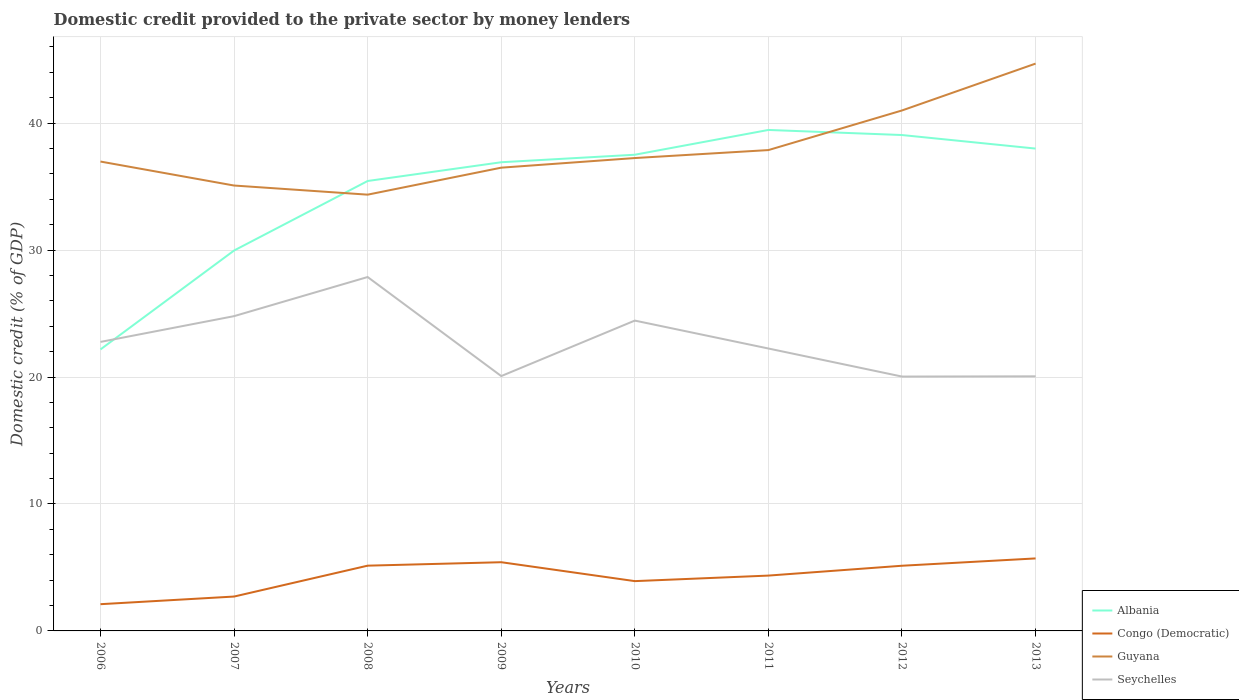Across all years, what is the maximum domestic credit provided to the private sector by money lenders in Congo (Democratic)?
Ensure brevity in your answer.  2.11. What is the total domestic credit provided to the private sector by money lenders in Seychelles in the graph?
Provide a succinct answer. 2.21. What is the difference between the highest and the second highest domestic credit provided to the private sector by money lenders in Congo (Democratic)?
Your answer should be very brief. 3.61. What is the difference between the highest and the lowest domestic credit provided to the private sector by money lenders in Congo (Democratic)?
Keep it short and to the point. 5. Is the domestic credit provided to the private sector by money lenders in Congo (Democratic) strictly greater than the domestic credit provided to the private sector by money lenders in Albania over the years?
Your response must be concise. Yes. Does the graph contain any zero values?
Offer a terse response. No. Does the graph contain grids?
Provide a succinct answer. Yes. Where does the legend appear in the graph?
Ensure brevity in your answer.  Bottom right. What is the title of the graph?
Ensure brevity in your answer.  Domestic credit provided to the private sector by money lenders. Does "Saudi Arabia" appear as one of the legend labels in the graph?
Make the answer very short. No. What is the label or title of the X-axis?
Keep it short and to the point. Years. What is the label or title of the Y-axis?
Provide a short and direct response. Domestic credit (% of GDP). What is the Domestic credit (% of GDP) of Albania in 2006?
Offer a terse response. 22.17. What is the Domestic credit (% of GDP) of Congo (Democratic) in 2006?
Give a very brief answer. 2.11. What is the Domestic credit (% of GDP) in Guyana in 2006?
Make the answer very short. 36.97. What is the Domestic credit (% of GDP) of Seychelles in 2006?
Your response must be concise. 22.76. What is the Domestic credit (% of GDP) of Albania in 2007?
Make the answer very short. 29.96. What is the Domestic credit (% of GDP) of Congo (Democratic) in 2007?
Keep it short and to the point. 2.71. What is the Domestic credit (% of GDP) of Guyana in 2007?
Your answer should be very brief. 35.08. What is the Domestic credit (% of GDP) in Seychelles in 2007?
Offer a very short reply. 24.79. What is the Domestic credit (% of GDP) of Albania in 2008?
Provide a short and direct response. 35.44. What is the Domestic credit (% of GDP) of Congo (Democratic) in 2008?
Provide a succinct answer. 5.14. What is the Domestic credit (% of GDP) in Guyana in 2008?
Your answer should be very brief. 34.36. What is the Domestic credit (% of GDP) of Seychelles in 2008?
Keep it short and to the point. 27.88. What is the Domestic credit (% of GDP) of Albania in 2009?
Keep it short and to the point. 36.92. What is the Domestic credit (% of GDP) of Congo (Democratic) in 2009?
Provide a short and direct response. 5.41. What is the Domestic credit (% of GDP) in Guyana in 2009?
Give a very brief answer. 36.49. What is the Domestic credit (% of GDP) in Seychelles in 2009?
Keep it short and to the point. 20.07. What is the Domestic credit (% of GDP) of Albania in 2010?
Provide a short and direct response. 37.51. What is the Domestic credit (% of GDP) in Congo (Democratic) in 2010?
Your answer should be compact. 3.92. What is the Domestic credit (% of GDP) in Guyana in 2010?
Ensure brevity in your answer.  37.25. What is the Domestic credit (% of GDP) of Seychelles in 2010?
Provide a succinct answer. 24.45. What is the Domestic credit (% of GDP) of Albania in 2011?
Your answer should be very brief. 39.46. What is the Domestic credit (% of GDP) of Congo (Democratic) in 2011?
Provide a short and direct response. 4.36. What is the Domestic credit (% of GDP) in Guyana in 2011?
Keep it short and to the point. 37.88. What is the Domestic credit (% of GDP) of Seychelles in 2011?
Provide a succinct answer. 22.25. What is the Domestic credit (% of GDP) in Albania in 2012?
Give a very brief answer. 39.06. What is the Domestic credit (% of GDP) of Congo (Democratic) in 2012?
Your answer should be compact. 5.13. What is the Domestic credit (% of GDP) of Guyana in 2012?
Provide a succinct answer. 41. What is the Domestic credit (% of GDP) of Seychelles in 2012?
Give a very brief answer. 20.04. What is the Domestic credit (% of GDP) in Albania in 2013?
Make the answer very short. 37.99. What is the Domestic credit (% of GDP) of Congo (Democratic) in 2013?
Offer a terse response. 5.71. What is the Domestic credit (% of GDP) in Guyana in 2013?
Your response must be concise. 44.69. What is the Domestic credit (% of GDP) in Seychelles in 2013?
Make the answer very short. 20.05. Across all years, what is the maximum Domestic credit (% of GDP) in Albania?
Offer a very short reply. 39.46. Across all years, what is the maximum Domestic credit (% of GDP) in Congo (Democratic)?
Ensure brevity in your answer.  5.71. Across all years, what is the maximum Domestic credit (% of GDP) in Guyana?
Your answer should be very brief. 44.69. Across all years, what is the maximum Domestic credit (% of GDP) of Seychelles?
Ensure brevity in your answer.  27.88. Across all years, what is the minimum Domestic credit (% of GDP) of Albania?
Give a very brief answer. 22.17. Across all years, what is the minimum Domestic credit (% of GDP) in Congo (Democratic)?
Your answer should be very brief. 2.11. Across all years, what is the minimum Domestic credit (% of GDP) of Guyana?
Make the answer very short. 34.36. Across all years, what is the minimum Domestic credit (% of GDP) in Seychelles?
Ensure brevity in your answer.  20.04. What is the total Domestic credit (% of GDP) in Albania in the graph?
Offer a very short reply. 278.52. What is the total Domestic credit (% of GDP) of Congo (Democratic) in the graph?
Make the answer very short. 34.49. What is the total Domestic credit (% of GDP) of Guyana in the graph?
Offer a terse response. 303.72. What is the total Domestic credit (% of GDP) of Seychelles in the graph?
Give a very brief answer. 182.29. What is the difference between the Domestic credit (% of GDP) of Albania in 2006 and that in 2007?
Provide a short and direct response. -7.79. What is the difference between the Domestic credit (% of GDP) in Congo (Democratic) in 2006 and that in 2007?
Give a very brief answer. -0.6. What is the difference between the Domestic credit (% of GDP) in Guyana in 2006 and that in 2007?
Offer a terse response. 1.89. What is the difference between the Domestic credit (% of GDP) in Seychelles in 2006 and that in 2007?
Your response must be concise. -2.03. What is the difference between the Domestic credit (% of GDP) in Albania in 2006 and that in 2008?
Keep it short and to the point. -13.27. What is the difference between the Domestic credit (% of GDP) in Congo (Democratic) in 2006 and that in 2008?
Keep it short and to the point. -3.03. What is the difference between the Domestic credit (% of GDP) of Guyana in 2006 and that in 2008?
Make the answer very short. 2.61. What is the difference between the Domestic credit (% of GDP) of Seychelles in 2006 and that in 2008?
Keep it short and to the point. -5.11. What is the difference between the Domestic credit (% of GDP) in Albania in 2006 and that in 2009?
Make the answer very short. -14.74. What is the difference between the Domestic credit (% of GDP) of Congo (Democratic) in 2006 and that in 2009?
Your response must be concise. -3.31. What is the difference between the Domestic credit (% of GDP) of Guyana in 2006 and that in 2009?
Keep it short and to the point. 0.48. What is the difference between the Domestic credit (% of GDP) of Seychelles in 2006 and that in 2009?
Offer a terse response. 2.69. What is the difference between the Domestic credit (% of GDP) of Albania in 2006 and that in 2010?
Provide a succinct answer. -15.34. What is the difference between the Domestic credit (% of GDP) in Congo (Democratic) in 2006 and that in 2010?
Your response must be concise. -1.82. What is the difference between the Domestic credit (% of GDP) in Guyana in 2006 and that in 2010?
Offer a terse response. -0.28. What is the difference between the Domestic credit (% of GDP) of Seychelles in 2006 and that in 2010?
Your answer should be compact. -1.68. What is the difference between the Domestic credit (% of GDP) of Albania in 2006 and that in 2011?
Keep it short and to the point. -17.29. What is the difference between the Domestic credit (% of GDP) in Congo (Democratic) in 2006 and that in 2011?
Provide a short and direct response. -2.25. What is the difference between the Domestic credit (% of GDP) of Guyana in 2006 and that in 2011?
Your answer should be very brief. -0.9. What is the difference between the Domestic credit (% of GDP) in Seychelles in 2006 and that in 2011?
Give a very brief answer. 0.52. What is the difference between the Domestic credit (% of GDP) in Albania in 2006 and that in 2012?
Offer a terse response. -16.89. What is the difference between the Domestic credit (% of GDP) in Congo (Democratic) in 2006 and that in 2012?
Your answer should be very brief. -3.03. What is the difference between the Domestic credit (% of GDP) in Guyana in 2006 and that in 2012?
Provide a short and direct response. -4.02. What is the difference between the Domestic credit (% of GDP) of Seychelles in 2006 and that in 2012?
Your answer should be very brief. 2.73. What is the difference between the Domestic credit (% of GDP) of Albania in 2006 and that in 2013?
Ensure brevity in your answer.  -15.82. What is the difference between the Domestic credit (% of GDP) of Congo (Democratic) in 2006 and that in 2013?
Provide a short and direct response. -3.6. What is the difference between the Domestic credit (% of GDP) of Guyana in 2006 and that in 2013?
Provide a short and direct response. -7.71. What is the difference between the Domestic credit (% of GDP) in Seychelles in 2006 and that in 2013?
Your answer should be compact. 2.71. What is the difference between the Domestic credit (% of GDP) of Albania in 2007 and that in 2008?
Keep it short and to the point. -5.48. What is the difference between the Domestic credit (% of GDP) of Congo (Democratic) in 2007 and that in 2008?
Give a very brief answer. -2.43. What is the difference between the Domestic credit (% of GDP) of Guyana in 2007 and that in 2008?
Provide a short and direct response. 0.72. What is the difference between the Domestic credit (% of GDP) of Seychelles in 2007 and that in 2008?
Ensure brevity in your answer.  -3.08. What is the difference between the Domestic credit (% of GDP) in Albania in 2007 and that in 2009?
Ensure brevity in your answer.  -6.95. What is the difference between the Domestic credit (% of GDP) in Congo (Democratic) in 2007 and that in 2009?
Your response must be concise. -2.7. What is the difference between the Domestic credit (% of GDP) of Guyana in 2007 and that in 2009?
Offer a terse response. -1.41. What is the difference between the Domestic credit (% of GDP) of Seychelles in 2007 and that in 2009?
Provide a succinct answer. 4.72. What is the difference between the Domestic credit (% of GDP) in Albania in 2007 and that in 2010?
Your answer should be compact. -7.54. What is the difference between the Domestic credit (% of GDP) in Congo (Democratic) in 2007 and that in 2010?
Your answer should be compact. -1.22. What is the difference between the Domestic credit (% of GDP) of Guyana in 2007 and that in 2010?
Your answer should be compact. -2.16. What is the difference between the Domestic credit (% of GDP) in Seychelles in 2007 and that in 2010?
Your answer should be very brief. 0.35. What is the difference between the Domestic credit (% of GDP) in Albania in 2007 and that in 2011?
Ensure brevity in your answer.  -9.5. What is the difference between the Domestic credit (% of GDP) of Congo (Democratic) in 2007 and that in 2011?
Give a very brief answer. -1.65. What is the difference between the Domestic credit (% of GDP) in Guyana in 2007 and that in 2011?
Your response must be concise. -2.79. What is the difference between the Domestic credit (% of GDP) of Seychelles in 2007 and that in 2011?
Make the answer very short. 2.55. What is the difference between the Domestic credit (% of GDP) of Albania in 2007 and that in 2012?
Your response must be concise. -9.1. What is the difference between the Domestic credit (% of GDP) of Congo (Democratic) in 2007 and that in 2012?
Offer a very short reply. -2.43. What is the difference between the Domestic credit (% of GDP) in Guyana in 2007 and that in 2012?
Your response must be concise. -5.91. What is the difference between the Domestic credit (% of GDP) in Seychelles in 2007 and that in 2012?
Provide a short and direct response. 4.76. What is the difference between the Domestic credit (% of GDP) of Albania in 2007 and that in 2013?
Ensure brevity in your answer.  -8.03. What is the difference between the Domestic credit (% of GDP) in Congo (Democratic) in 2007 and that in 2013?
Make the answer very short. -3. What is the difference between the Domestic credit (% of GDP) in Guyana in 2007 and that in 2013?
Offer a terse response. -9.6. What is the difference between the Domestic credit (% of GDP) in Seychelles in 2007 and that in 2013?
Your answer should be very brief. 4.74. What is the difference between the Domestic credit (% of GDP) in Albania in 2008 and that in 2009?
Your response must be concise. -1.48. What is the difference between the Domestic credit (% of GDP) of Congo (Democratic) in 2008 and that in 2009?
Offer a terse response. -0.27. What is the difference between the Domestic credit (% of GDP) of Guyana in 2008 and that in 2009?
Your answer should be very brief. -2.13. What is the difference between the Domestic credit (% of GDP) in Seychelles in 2008 and that in 2009?
Give a very brief answer. 7.8. What is the difference between the Domestic credit (% of GDP) in Albania in 2008 and that in 2010?
Give a very brief answer. -2.07. What is the difference between the Domestic credit (% of GDP) of Congo (Democratic) in 2008 and that in 2010?
Ensure brevity in your answer.  1.22. What is the difference between the Domestic credit (% of GDP) of Guyana in 2008 and that in 2010?
Provide a succinct answer. -2.88. What is the difference between the Domestic credit (% of GDP) of Seychelles in 2008 and that in 2010?
Offer a terse response. 3.43. What is the difference between the Domestic credit (% of GDP) in Albania in 2008 and that in 2011?
Make the answer very short. -4.02. What is the difference between the Domestic credit (% of GDP) in Congo (Democratic) in 2008 and that in 2011?
Provide a succinct answer. 0.78. What is the difference between the Domestic credit (% of GDP) in Guyana in 2008 and that in 2011?
Ensure brevity in your answer.  -3.51. What is the difference between the Domestic credit (% of GDP) of Seychelles in 2008 and that in 2011?
Offer a very short reply. 5.63. What is the difference between the Domestic credit (% of GDP) in Albania in 2008 and that in 2012?
Provide a succinct answer. -3.62. What is the difference between the Domestic credit (% of GDP) of Congo (Democratic) in 2008 and that in 2012?
Offer a very short reply. 0.01. What is the difference between the Domestic credit (% of GDP) in Guyana in 2008 and that in 2012?
Keep it short and to the point. -6.63. What is the difference between the Domestic credit (% of GDP) of Seychelles in 2008 and that in 2012?
Your response must be concise. 7.84. What is the difference between the Domestic credit (% of GDP) in Albania in 2008 and that in 2013?
Your answer should be very brief. -2.55. What is the difference between the Domestic credit (% of GDP) of Congo (Democratic) in 2008 and that in 2013?
Give a very brief answer. -0.57. What is the difference between the Domestic credit (% of GDP) in Guyana in 2008 and that in 2013?
Make the answer very short. -10.32. What is the difference between the Domestic credit (% of GDP) of Seychelles in 2008 and that in 2013?
Offer a terse response. 7.82. What is the difference between the Domestic credit (% of GDP) of Albania in 2009 and that in 2010?
Offer a very short reply. -0.59. What is the difference between the Domestic credit (% of GDP) in Congo (Democratic) in 2009 and that in 2010?
Your answer should be very brief. 1.49. What is the difference between the Domestic credit (% of GDP) of Guyana in 2009 and that in 2010?
Make the answer very short. -0.76. What is the difference between the Domestic credit (% of GDP) in Seychelles in 2009 and that in 2010?
Make the answer very short. -4.37. What is the difference between the Domestic credit (% of GDP) in Albania in 2009 and that in 2011?
Make the answer very short. -2.54. What is the difference between the Domestic credit (% of GDP) of Congo (Democratic) in 2009 and that in 2011?
Offer a terse response. 1.05. What is the difference between the Domestic credit (% of GDP) of Guyana in 2009 and that in 2011?
Keep it short and to the point. -1.39. What is the difference between the Domestic credit (% of GDP) in Seychelles in 2009 and that in 2011?
Your response must be concise. -2.17. What is the difference between the Domestic credit (% of GDP) of Albania in 2009 and that in 2012?
Your answer should be very brief. -2.14. What is the difference between the Domestic credit (% of GDP) in Congo (Democratic) in 2009 and that in 2012?
Provide a short and direct response. 0.28. What is the difference between the Domestic credit (% of GDP) in Guyana in 2009 and that in 2012?
Your response must be concise. -4.51. What is the difference between the Domestic credit (% of GDP) in Seychelles in 2009 and that in 2012?
Offer a terse response. 0.04. What is the difference between the Domestic credit (% of GDP) in Albania in 2009 and that in 2013?
Provide a short and direct response. -1.08. What is the difference between the Domestic credit (% of GDP) in Congo (Democratic) in 2009 and that in 2013?
Give a very brief answer. -0.3. What is the difference between the Domestic credit (% of GDP) in Guyana in 2009 and that in 2013?
Make the answer very short. -8.2. What is the difference between the Domestic credit (% of GDP) in Seychelles in 2009 and that in 2013?
Provide a succinct answer. 0.02. What is the difference between the Domestic credit (% of GDP) of Albania in 2010 and that in 2011?
Your answer should be very brief. -1.95. What is the difference between the Domestic credit (% of GDP) of Congo (Democratic) in 2010 and that in 2011?
Give a very brief answer. -0.44. What is the difference between the Domestic credit (% of GDP) of Guyana in 2010 and that in 2011?
Your answer should be compact. -0.63. What is the difference between the Domestic credit (% of GDP) in Seychelles in 2010 and that in 2011?
Your response must be concise. 2.2. What is the difference between the Domestic credit (% of GDP) in Albania in 2010 and that in 2012?
Your answer should be very brief. -1.55. What is the difference between the Domestic credit (% of GDP) in Congo (Democratic) in 2010 and that in 2012?
Your answer should be very brief. -1.21. What is the difference between the Domestic credit (% of GDP) of Guyana in 2010 and that in 2012?
Your answer should be compact. -3.75. What is the difference between the Domestic credit (% of GDP) of Seychelles in 2010 and that in 2012?
Offer a very short reply. 4.41. What is the difference between the Domestic credit (% of GDP) of Albania in 2010 and that in 2013?
Your answer should be compact. -0.49. What is the difference between the Domestic credit (% of GDP) of Congo (Democratic) in 2010 and that in 2013?
Your answer should be very brief. -1.79. What is the difference between the Domestic credit (% of GDP) of Guyana in 2010 and that in 2013?
Your response must be concise. -7.44. What is the difference between the Domestic credit (% of GDP) of Seychelles in 2010 and that in 2013?
Provide a short and direct response. 4.39. What is the difference between the Domestic credit (% of GDP) of Albania in 2011 and that in 2012?
Make the answer very short. 0.4. What is the difference between the Domestic credit (% of GDP) of Congo (Democratic) in 2011 and that in 2012?
Your answer should be compact. -0.78. What is the difference between the Domestic credit (% of GDP) in Guyana in 2011 and that in 2012?
Provide a succinct answer. -3.12. What is the difference between the Domestic credit (% of GDP) of Seychelles in 2011 and that in 2012?
Provide a succinct answer. 2.21. What is the difference between the Domestic credit (% of GDP) of Albania in 2011 and that in 2013?
Your answer should be compact. 1.47. What is the difference between the Domestic credit (% of GDP) in Congo (Democratic) in 2011 and that in 2013?
Your answer should be compact. -1.35. What is the difference between the Domestic credit (% of GDP) of Guyana in 2011 and that in 2013?
Keep it short and to the point. -6.81. What is the difference between the Domestic credit (% of GDP) of Seychelles in 2011 and that in 2013?
Make the answer very short. 2.19. What is the difference between the Domestic credit (% of GDP) of Albania in 2012 and that in 2013?
Provide a short and direct response. 1.07. What is the difference between the Domestic credit (% of GDP) in Congo (Democratic) in 2012 and that in 2013?
Your answer should be very brief. -0.58. What is the difference between the Domestic credit (% of GDP) of Guyana in 2012 and that in 2013?
Make the answer very short. -3.69. What is the difference between the Domestic credit (% of GDP) of Seychelles in 2012 and that in 2013?
Make the answer very short. -0.02. What is the difference between the Domestic credit (% of GDP) in Albania in 2006 and the Domestic credit (% of GDP) in Congo (Democratic) in 2007?
Your answer should be very brief. 19.47. What is the difference between the Domestic credit (% of GDP) of Albania in 2006 and the Domestic credit (% of GDP) of Guyana in 2007?
Your answer should be very brief. -12.91. What is the difference between the Domestic credit (% of GDP) in Albania in 2006 and the Domestic credit (% of GDP) in Seychelles in 2007?
Your response must be concise. -2.62. What is the difference between the Domestic credit (% of GDP) of Congo (Democratic) in 2006 and the Domestic credit (% of GDP) of Guyana in 2007?
Your answer should be compact. -32.98. What is the difference between the Domestic credit (% of GDP) of Congo (Democratic) in 2006 and the Domestic credit (% of GDP) of Seychelles in 2007?
Offer a terse response. -22.69. What is the difference between the Domestic credit (% of GDP) in Guyana in 2006 and the Domestic credit (% of GDP) in Seychelles in 2007?
Your answer should be compact. 12.18. What is the difference between the Domestic credit (% of GDP) of Albania in 2006 and the Domestic credit (% of GDP) of Congo (Democratic) in 2008?
Provide a succinct answer. 17.03. What is the difference between the Domestic credit (% of GDP) in Albania in 2006 and the Domestic credit (% of GDP) in Guyana in 2008?
Keep it short and to the point. -12.19. What is the difference between the Domestic credit (% of GDP) of Albania in 2006 and the Domestic credit (% of GDP) of Seychelles in 2008?
Ensure brevity in your answer.  -5.7. What is the difference between the Domestic credit (% of GDP) of Congo (Democratic) in 2006 and the Domestic credit (% of GDP) of Guyana in 2008?
Make the answer very short. -32.26. What is the difference between the Domestic credit (% of GDP) of Congo (Democratic) in 2006 and the Domestic credit (% of GDP) of Seychelles in 2008?
Your answer should be very brief. -25.77. What is the difference between the Domestic credit (% of GDP) in Guyana in 2006 and the Domestic credit (% of GDP) in Seychelles in 2008?
Provide a succinct answer. 9.1. What is the difference between the Domestic credit (% of GDP) in Albania in 2006 and the Domestic credit (% of GDP) in Congo (Democratic) in 2009?
Give a very brief answer. 16.76. What is the difference between the Domestic credit (% of GDP) in Albania in 2006 and the Domestic credit (% of GDP) in Guyana in 2009?
Your answer should be compact. -14.32. What is the difference between the Domestic credit (% of GDP) in Albania in 2006 and the Domestic credit (% of GDP) in Seychelles in 2009?
Provide a succinct answer. 2.1. What is the difference between the Domestic credit (% of GDP) in Congo (Democratic) in 2006 and the Domestic credit (% of GDP) in Guyana in 2009?
Your answer should be compact. -34.38. What is the difference between the Domestic credit (% of GDP) of Congo (Democratic) in 2006 and the Domestic credit (% of GDP) of Seychelles in 2009?
Offer a terse response. -17.97. What is the difference between the Domestic credit (% of GDP) of Guyana in 2006 and the Domestic credit (% of GDP) of Seychelles in 2009?
Ensure brevity in your answer.  16.9. What is the difference between the Domestic credit (% of GDP) in Albania in 2006 and the Domestic credit (% of GDP) in Congo (Democratic) in 2010?
Your response must be concise. 18.25. What is the difference between the Domestic credit (% of GDP) in Albania in 2006 and the Domestic credit (% of GDP) in Guyana in 2010?
Keep it short and to the point. -15.07. What is the difference between the Domestic credit (% of GDP) of Albania in 2006 and the Domestic credit (% of GDP) of Seychelles in 2010?
Keep it short and to the point. -2.27. What is the difference between the Domestic credit (% of GDP) of Congo (Democratic) in 2006 and the Domestic credit (% of GDP) of Guyana in 2010?
Give a very brief answer. -35.14. What is the difference between the Domestic credit (% of GDP) in Congo (Democratic) in 2006 and the Domestic credit (% of GDP) in Seychelles in 2010?
Make the answer very short. -22.34. What is the difference between the Domestic credit (% of GDP) of Guyana in 2006 and the Domestic credit (% of GDP) of Seychelles in 2010?
Provide a succinct answer. 12.53. What is the difference between the Domestic credit (% of GDP) in Albania in 2006 and the Domestic credit (% of GDP) in Congo (Democratic) in 2011?
Ensure brevity in your answer.  17.81. What is the difference between the Domestic credit (% of GDP) in Albania in 2006 and the Domestic credit (% of GDP) in Guyana in 2011?
Offer a very short reply. -15.7. What is the difference between the Domestic credit (% of GDP) of Albania in 2006 and the Domestic credit (% of GDP) of Seychelles in 2011?
Give a very brief answer. -0.07. What is the difference between the Domestic credit (% of GDP) in Congo (Democratic) in 2006 and the Domestic credit (% of GDP) in Guyana in 2011?
Keep it short and to the point. -35.77. What is the difference between the Domestic credit (% of GDP) in Congo (Democratic) in 2006 and the Domestic credit (% of GDP) in Seychelles in 2011?
Offer a very short reply. -20.14. What is the difference between the Domestic credit (% of GDP) of Guyana in 2006 and the Domestic credit (% of GDP) of Seychelles in 2011?
Your answer should be compact. 14.73. What is the difference between the Domestic credit (% of GDP) of Albania in 2006 and the Domestic credit (% of GDP) of Congo (Democratic) in 2012?
Keep it short and to the point. 17.04. What is the difference between the Domestic credit (% of GDP) in Albania in 2006 and the Domestic credit (% of GDP) in Guyana in 2012?
Provide a short and direct response. -18.82. What is the difference between the Domestic credit (% of GDP) of Albania in 2006 and the Domestic credit (% of GDP) of Seychelles in 2012?
Your answer should be compact. 2.14. What is the difference between the Domestic credit (% of GDP) in Congo (Democratic) in 2006 and the Domestic credit (% of GDP) in Guyana in 2012?
Keep it short and to the point. -38.89. What is the difference between the Domestic credit (% of GDP) of Congo (Democratic) in 2006 and the Domestic credit (% of GDP) of Seychelles in 2012?
Ensure brevity in your answer.  -17.93. What is the difference between the Domestic credit (% of GDP) in Guyana in 2006 and the Domestic credit (% of GDP) in Seychelles in 2012?
Offer a terse response. 16.94. What is the difference between the Domestic credit (% of GDP) of Albania in 2006 and the Domestic credit (% of GDP) of Congo (Democratic) in 2013?
Offer a terse response. 16.46. What is the difference between the Domestic credit (% of GDP) of Albania in 2006 and the Domestic credit (% of GDP) of Guyana in 2013?
Provide a short and direct response. -22.51. What is the difference between the Domestic credit (% of GDP) of Albania in 2006 and the Domestic credit (% of GDP) of Seychelles in 2013?
Your answer should be very brief. 2.12. What is the difference between the Domestic credit (% of GDP) of Congo (Democratic) in 2006 and the Domestic credit (% of GDP) of Guyana in 2013?
Make the answer very short. -42.58. What is the difference between the Domestic credit (% of GDP) of Congo (Democratic) in 2006 and the Domestic credit (% of GDP) of Seychelles in 2013?
Offer a terse response. -17.95. What is the difference between the Domestic credit (% of GDP) of Guyana in 2006 and the Domestic credit (% of GDP) of Seychelles in 2013?
Offer a very short reply. 16.92. What is the difference between the Domestic credit (% of GDP) in Albania in 2007 and the Domestic credit (% of GDP) in Congo (Democratic) in 2008?
Offer a very short reply. 24.82. What is the difference between the Domestic credit (% of GDP) of Albania in 2007 and the Domestic credit (% of GDP) of Guyana in 2008?
Make the answer very short. -4.4. What is the difference between the Domestic credit (% of GDP) of Albania in 2007 and the Domestic credit (% of GDP) of Seychelles in 2008?
Provide a succinct answer. 2.09. What is the difference between the Domestic credit (% of GDP) of Congo (Democratic) in 2007 and the Domestic credit (% of GDP) of Guyana in 2008?
Offer a very short reply. -31.66. What is the difference between the Domestic credit (% of GDP) of Congo (Democratic) in 2007 and the Domestic credit (% of GDP) of Seychelles in 2008?
Your answer should be compact. -25.17. What is the difference between the Domestic credit (% of GDP) in Guyana in 2007 and the Domestic credit (% of GDP) in Seychelles in 2008?
Your answer should be very brief. 7.21. What is the difference between the Domestic credit (% of GDP) of Albania in 2007 and the Domestic credit (% of GDP) of Congo (Democratic) in 2009?
Make the answer very short. 24.55. What is the difference between the Domestic credit (% of GDP) of Albania in 2007 and the Domestic credit (% of GDP) of Guyana in 2009?
Your answer should be very brief. -6.53. What is the difference between the Domestic credit (% of GDP) of Albania in 2007 and the Domestic credit (% of GDP) of Seychelles in 2009?
Offer a very short reply. 9.89. What is the difference between the Domestic credit (% of GDP) in Congo (Democratic) in 2007 and the Domestic credit (% of GDP) in Guyana in 2009?
Keep it short and to the point. -33.78. What is the difference between the Domestic credit (% of GDP) of Congo (Democratic) in 2007 and the Domestic credit (% of GDP) of Seychelles in 2009?
Your response must be concise. -17.37. What is the difference between the Domestic credit (% of GDP) in Guyana in 2007 and the Domestic credit (% of GDP) in Seychelles in 2009?
Your answer should be compact. 15.01. What is the difference between the Domestic credit (% of GDP) in Albania in 2007 and the Domestic credit (% of GDP) in Congo (Democratic) in 2010?
Offer a terse response. 26.04. What is the difference between the Domestic credit (% of GDP) in Albania in 2007 and the Domestic credit (% of GDP) in Guyana in 2010?
Make the answer very short. -7.28. What is the difference between the Domestic credit (% of GDP) in Albania in 2007 and the Domestic credit (% of GDP) in Seychelles in 2010?
Make the answer very short. 5.52. What is the difference between the Domestic credit (% of GDP) of Congo (Democratic) in 2007 and the Domestic credit (% of GDP) of Guyana in 2010?
Offer a terse response. -34.54. What is the difference between the Domestic credit (% of GDP) in Congo (Democratic) in 2007 and the Domestic credit (% of GDP) in Seychelles in 2010?
Your response must be concise. -21.74. What is the difference between the Domestic credit (% of GDP) of Guyana in 2007 and the Domestic credit (% of GDP) of Seychelles in 2010?
Offer a very short reply. 10.64. What is the difference between the Domestic credit (% of GDP) of Albania in 2007 and the Domestic credit (% of GDP) of Congo (Democratic) in 2011?
Offer a very short reply. 25.61. What is the difference between the Domestic credit (% of GDP) of Albania in 2007 and the Domestic credit (% of GDP) of Guyana in 2011?
Provide a succinct answer. -7.91. What is the difference between the Domestic credit (% of GDP) in Albania in 2007 and the Domestic credit (% of GDP) in Seychelles in 2011?
Offer a very short reply. 7.72. What is the difference between the Domestic credit (% of GDP) of Congo (Democratic) in 2007 and the Domestic credit (% of GDP) of Guyana in 2011?
Keep it short and to the point. -35.17. What is the difference between the Domestic credit (% of GDP) of Congo (Democratic) in 2007 and the Domestic credit (% of GDP) of Seychelles in 2011?
Offer a terse response. -19.54. What is the difference between the Domestic credit (% of GDP) in Guyana in 2007 and the Domestic credit (% of GDP) in Seychelles in 2011?
Your answer should be very brief. 12.84. What is the difference between the Domestic credit (% of GDP) of Albania in 2007 and the Domestic credit (% of GDP) of Congo (Democratic) in 2012?
Your response must be concise. 24.83. What is the difference between the Domestic credit (% of GDP) in Albania in 2007 and the Domestic credit (% of GDP) in Guyana in 2012?
Offer a very short reply. -11.03. What is the difference between the Domestic credit (% of GDP) in Albania in 2007 and the Domestic credit (% of GDP) in Seychelles in 2012?
Keep it short and to the point. 9.93. What is the difference between the Domestic credit (% of GDP) in Congo (Democratic) in 2007 and the Domestic credit (% of GDP) in Guyana in 2012?
Your response must be concise. -38.29. What is the difference between the Domestic credit (% of GDP) in Congo (Democratic) in 2007 and the Domestic credit (% of GDP) in Seychelles in 2012?
Give a very brief answer. -17.33. What is the difference between the Domestic credit (% of GDP) of Guyana in 2007 and the Domestic credit (% of GDP) of Seychelles in 2012?
Offer a terse response. 15.05. What is the difference between the Domestic credit (% of GDP) in Albania in 2007 and the Domestic credit (% of GDP) in Congo (Democratic) in 2013?
Make the answer very short. 24.25. What is the difference between the Domestic credit (% of GDP) of Albania in 2007 and the Domestic credit (% of GDP) of Guyana in 2013?
Provide a succinct answer. -14.72. What is the difference between the Domestic credit (% of GDP) of Albania in 2007 and the Domestic credit (% of GDP) of Seychelles in 2013?
Your answer should be compact. 9.91. What is the difference between the Domestic credit (% of GDP) of Congo (Democratic) in 2007 and the Domestic credit (% of GDP) of Guyana in 2013?
Your answer should be very brief. -41.98. What is the difference between the Domestic credit (% of GDP) of Congo (Democratic) in 2007 and the Domestic credit (% of GDP) of Seychelles in 2013?
Your answer should be very brief. -17.35. What is the difference between the Domestic credit (% of GDP) of Guyana in 2007 and the Domestic credit (% of GDP) of Seychelles in 2013?
Your response must be concise. 15.03. What is the difference between the Domestic credit (% of GDP) in Albania in 2008 and the Domestic credit (% of GDP) in Congo (Democratic) in 2009?
Your answer should be very brief. 30.03. What is the difference between the Domestic credit (% of GDP) of Albania in 2008 and the Domestic credit (% of GDP) of Guyana in 2009?
Offer a very short reply. -1.05. What is the difference between the Domestic credit (% of GDP) of Albania in 2008 and the Domestic credit (% of GDP) of Seychelles in 2009?
Your answer should be very brief. 15.37. What is the difference between the Domestic credit (% of GDP) of Congo (Democratic) in 2008 and the Domestic credit (% of GDP) of Guyana in 2009?
Ensure brevity in your answer.  -31.35. What is the difference between the Domestic credit (% of GDP) in Congo (Democratic) in 2008 and the Domestic credit (% of GDP) in Seychelles in 2009?
Your response must be concise. -14.93. What is the difference between the Domestic credit (% of GDP) of Guyana in 2008 and the Domestic credit (% of GDP) of Seychelles in 2009?
Provide a succinct answer. 14.29. What is the difference between the Domestic credit (% of GDP) in Albania in 2008 and the Domestic credit (% of GDP) in Congo (Democratic) in 2010?
Provide a succinct answer. 31.52. What is the difference between the Domestic credit (% of GDP) in Albania in 2008 and the Domestic credit (% of GDP) in Guyana in 2010?
Make the answer very short. -1.81. What is the difference between the Domestic credit (% of GDP) of Albania in 2008 and the Domestic credit (% of GDP) of Seychelles in 2010?
Your response must be concise. 10.99. What is the difference between the Domestic credit (% of GDP) of Congo (Democratic) in 2008 and the Domestic credit (% of GDP) of Guyana in 2010?
Ensure brevity in your answer.  -32.11. What is the difference between the Domestic credit (% of GDP) of Congo (Democratic) in 2008 and the Domestic credit (% of GDP) of Seychelles in 2010?
Give a very brief answer. -19.3. What is the difference between the Domestic credit (% of GDP) of Guyana in 2008 and the Domestic credit (% of GDP) of Seychelles in 2010?
Provide a succinct answer. 9.92. What is the difference between the Domestic credit (% of GDP) of Albania in 2008 and the Domestic credit (% of GDP) of Congo (Democratic) in 2011?
Keep it short and to the point. 31.08. What is the difference between the Domestic credit (% of GDP) in Albania in 2008 and the Domestic credit (% of GDP) in Guyana in 2011?
Your response must be concise. -2.44. What is the difference between the Domestic credit (% of GDP) of Albania in 2008 and the Domestic credit (% of GDP) of Seychelles in 2011?
Provide a short and direct response. 13.19. What is the difference between the Domestic credit (% of GDP) in Congo (Democratic) in 2008 and the Domestic credit (% of GDP) in Guyana in 2011?
Provide a short and direct response. -32.74. What is the difference between the Domestic credit (% of GDP) of Congo (Democratic) in 2008 and the Domestic credit (% of GDP) of Seychelles in 2011?
Provide a short and direct response. -17.11. What is the difference between the Domestic credit (% of GDP) of Guyana in 2008 and the Domestic credit (% of GDP) of Seychelles in 2011?
Give a very brief answer. 12.12. What is the difference between the Domestic credit (% of GDP) of Albania in 2008 and the Domestic credit (% of GDP) of Congo (Democratic) in 2012?
Provide a short and direct response. 30.31. What is the difference between the Domestic credit (% of GDP) of Albania in 2008 and the Domestic credit (% of GDP) of Guyana in 2012?
Provide a short and direct response. -5.56. What is the difference between the Domestic credit (% of GDP) in Albania in 2008 and the Domestic credit (% of GDP) in Seychelles in 2012?
Offer a terse response. 15.4. What is the difference between the Domestic credit (% of GDP) in Congo (Democratic) in 2008 and the Domestic credit (% of GDP) in Guyana in 2012?
Ensure brevity in your answer.  -35.86. What is the difference between the Domestic credit (% of GDP) in Congo (Democratic) in 2008 and the Domestic credit (% of GDP) in Seychelles in 2012?
Ensure brevity in your answer.  -14.9. What is the difference between the Domestic credit (% of GDP) in Guyana in 2008 and the Domestic credit (% of GDP) in Seychelles in 2012?
Provide a short and direct response. 14.33. What is the difference between the Domestic credit (% of GDP) in Albania in 2008 and the Domestic credit (% of GDP) in Congo (Democratic) in 2013?
Your answer should be very brief. 29.73. What is the difference between the Domestic credit (% of GDP) of Albania in 2008 and the Domestic credit (% of GDP) of Guyana in 2013?
Your response must be concise. -9.25. What is the difference between the Domestic credit (% of GDP) in Albania in 2008 and the Domestic credit (% of GDP) in Seychelles in 2013?
Your answer should be very brief. 15.39. What is the difference between the Domestic credit (% of GDP) of Congo (Democratic) in 2008 and the Domestic credit (% of GDP) of Guyana in 2013?
Give a very brief answer. -39.55. What is the difference between the Domestic credit (% of GDP) in Congo (Democratic) in 2008 and the Domestic credit (% of GDP) in Seychelles in 2013?
Give a very brief answer. -14.91. What is the difference between the Domestic credit (% of GDP) of Guyana in 2008 and the Domestic credit (% of GDP) of Seychelles in 2013?
Your response must be concise. 14.31. What is the difference between the Domestic credit (% of GDP) of Albania in 2009 and the Domestic credit (% of GDP) of Congo (Democratic) in 2010?
Ensure brevity in your answer.  33. What is the difference between the Domestic credit (% of GDP) in Albania in 2009 and the Domestic credit (% of GDP) in Guyana in 2010?
Your answer should be very brief. -0.33. What is the difference between the Domestic credit (% of GDP) of Albania in 2009 and the Domestic credit (% of GDP) of Seychelles in 2010?
Your response must be concise. 12.47. What is the difference between the Domestic credit (% of GDP) in Congo (Democratic) in 2009 and the Domestic credit (% of GDP) in Guyana in 2010?
Offer a very short reply. -31.84. What is the difference between the Domestic credit (% of GDP) in Congo (Democratic) in 2009 and the Domestic credit (% of GDP) in Seychelles in 2010?
Your response must be concise. -19.03. What is the difference between the Domestic credit (% of GDP) in Guyana in 2009 and the Domestic credit (% of GDP) in Seychelles in 2010?
Keep it short and to the point. 12.04. What is the difference between the Domestic credit (% of GDP) in Albania in 2009 and the Domestic credit (% of GDP) in Congo (Democratic) in 2011?
Give a very brief answer. 32.56. What is the difference between the Domestic credit (% of GDP) in Albania in 2009 and the Domestic credit (% of GDP) in Guyana in 2011?
Give a very brief answer. -0.96. What is the difference between the Domestic credit (% of GDP) in Albania in 2009 and the Domestic credit (% of GDP) in Seychelles in 2011?
Provide a succinct answer. 14.67. What is the difference between the Domestic credit (% of GDP) in Congo (Democratic) in 2009 and the Domestic credit (% of GDP) in Guyana in 2011?
Provide a succinct answer. -32.46. What is the difference between the Domestic credit (% of GDP) in Congo (Democratic) in 2009 and the Domestic credit (% of GDP) in Seychelles in 2011?
Provide a short and direct response. -16.83. What is the difference between the Domestic credit (% of GDP) of Guyana in 2009 and the Domestic credit (% of GDP) of Seychelles in 2011?
Give a very brief answer. 14.24. What is the difference between the Domestic credit (% of GDP) in Albania in 2009 and the Domestic credit (% of GDP) in Congo (Democratic) in 2012?
Your response must be concise. 31.78. What is the difference between the Domestic credit (% of GDP) in Albania in 2009 and the Domestic credit (% of GDP) in Guyana in 2012?
Keep it short and to the point. -4.08. What is the difference between the Domestic credit (% of GDP) of Albania in 2009 and the Domestic credit (% of GDP) of Seychelles in 2012?
Offer a terse response. 16.88. What is the difference between the Domestic credit (% of GDP) in Congo (Democratic) in 2009 and the Domestic credit (% of GDP) in Guyana in 2012?
Keep it short and to the point. -35.58. What is the difference between the Domestic credit (% of GDP) in Congo (Democratic) in 2009 and the Domestic credit (% of GDP) in Seychelles in 2012?
Keep it short and to the point. -14.62. What is the difference between the Domestic credit (% of GDP) in Guyana in 2009 and the Domestic credit (% of GDP) in Seychelles in 2012?
Offer a very short reply. 16.45. What is the difference between the Domestic credit (% of GDP) of Albania in 2009 and the Domestic credit (% of GDP) of Congo (Democratic) in 2013?
Offer a terse response. 31.21. What is the difference between the Domestic credit (% of GDP) of Albania in 2009 and the Domestic credit (% of GDP) of Guyana in 2013?
Provide a succinct answer. -7.77. What is the difference between the Domestic credit (% of GDP) in Albania in 2009 and the Domestic credit (% of GDP) in Seychelles in 2013?
Your answer should be compact. 16.86. What is the difference between the Domestic credit (% of GDP) of Congo (Democratic) in 2009 and the Domestic credit (% of GDP) of Guyana in 2013?
Provide a succinct answer. -39.27. What is the difference between the Domestic credit (% of GDP) of Congo (Democratic) in 2009 and the Domestic credit (% of GDP) of Seychelles in 2013?
Give a very brief answer. -14.64. What is the difference between the Domestic credit (% of GDP) in Guyana in 2009 and the Domestic credit (% of GDP) in Seychelles in 2013?
Offer a very short reply. 16.44. What is the difference between the Domestic credit (% of GDP) in Albania in 2010 and the Domestic credit (% of GDP) in Congo (Democratic) in 2011?
Provide a short and direct response. 33.15. What is the difference between the Domestic credit (% of GDP) in Albania in 2010 and the Domestic credit (% of GDP) in Guyana in 2011?
Offer a terse response. -0.37. What is the difference between the Domestic credit (% of GDP) in Albania in 2010 and the Domestic credit (% of GDP) in Seychelles in 2011?
Offer a very short reply. 15.26. What is the difference between the Domestic credit (% of GDP) of Congo (Democratic) in 2010 and the Domestic credit (% of GDP) of Guyana in 2011?
Your answer should be very brief. -33.95. What is the difference between the Domestic credit (% of GDP) of Congo (Democratic) in 2010 and the Domestic credit (% of GDP) of Seychelles in 2011?
Make the answer very short. -18.32. What is the difference between the Domestic credit (% of GDP) of Guyana in 2010 and the Domestic credit (% of GDP) of Seychelles in 2011?
Give a very brief answer. 15. What is the difference between the Domestic credit (% of GDP) of Albania in 2010 and the Domestic credit (% of GDP) of Congo (Democratic) in 2012?
Your response must be concise. 32.37. What is the difference between the Domestic credit (% of GDP) in Albania in 2010 and the Domestic credit (% of GDP) in Guyana in 2012?
Your answer should be compact. -3.49. What is the difference between the Domestic credit (% of GDP) in Albania in 2010 and the Domestic credit (% of GDP) in Seychelles in 2012?
Your answer should be compact. 17.47. What is the difference between the Domestic credit (% of GDP) in Congo (Democratic) in 2010 and the Domestic credit (% of GDP) in Guyana in 2012?
Make the answer very short. -37.07. What is the difference between the Domestic credit (% of GDP) in Congo (Democratic) in 2010 and the Domestic credit (% of GDP) in Seychelles in 2012?
Offer a very short reply. -16.11. What is the difference between the Domestic credit (% of GDP) in Guyana in 2010 and the Domestic credit (% of GDP) in Seychelles in 2012?
Make the answer very short. 17.21. What is the difference between the Domestic credit (% of GDP) in Albania in 2010 and the Domestic credit (% of GDP) in Congo (Democratic) in 2013?
Your answer should be very brief. 31.8. What is the difference between the Domestic credit (% of GDP) in Albania in 2010 and the Domestic credit (% of GDP) in Guyana in 2013?
Keep it short and to the point. -7.18. What is the difference between the Domestic credit (% of GDP) in Albania in 2010 and the Domestic credit (% of GDP) in Seychelles in 2013?
Your answer should be compact. 17.45. What is the difference between the Domestic credit (% of GDP) in Congo (Democratic) in 2010 and the Domestic credit (% of GDP) in Guyana in 2013?
Ensure brevity in your answer.  -40.76. What is the difference between the Domestic credit (% of GDP) of Congo (Democratic) in 2010 and the Domestic credit (% of GDP) of Seychelles in 2013?
Offer a very short reply. -16.13. What is the difference between the Domestic credit (% of GDP) of Guyana in 2010 and the Domestic credit (% of GDP) of Seychelles in 2013?
Give a very brief answer. 17.19. What is the difference between the Domestic credit (% of GDP) in Albania in 2011 and the Domestic credit (% of GDP) in Congo (Democratic) in 2012?
Your answer should be compact. 34.33. What is the difference between the Domestic credit (% of GDP) of Albania in 2011 and the Domestic credit (% of GDP) of Guyana in 2012?
Ensure brevity in your answer.  -1.54. What is the difference between the Domestic credit (% of GDP) in Albania in 2011 and the Domestic credit (% of GDP) in Seychelles in 2012?
Offer a terse response. 19.43. What is the difference between the Domestic credit (% of GDP) of Congo (Democratic) in 2011 and the Domestic credit (% of GDP) of Guyana in 2012?
Offer a very short reply. -36.64. What is the difference between the Domestic credit (% of GDP) in Congo (Democratic) in 2011 and the Domestic credit (% of GDP) in Seychelles in 2012?
Keep it short and to the point. -15.68. What is the difference between the Domestic credit (% of GDP) of Guyana in 2011 and the Domestic credit (% of GDP) of Seychelles in 2012?
Your response must be concise. 17.84. What is the difference between the Domestic credit (% of GDP) of Albania in 2011 and the Domestic credit (% of GDP) of Congo (Democratic) in 2013?
Offer a very short reply. 33.75. What is the difference between the Domestic credit (% of GDP) of Albania in 2011 and the Domestic credit (% of GDP) of Guyana in 2013?
Your answer should be compact. -5.23. What is the difference between the Domestic credit (% of GDP) of Albania in 2011 and the Domestic credit (% of GDP) of Seychelles in 2013?
Give a very brief answer. 19.41. What is the difference between the Domestic credit (% of GDP) in Congo (Democratic) in 2011 and the Domestic credit (% of GDP) in Guyana in 2013?
Provide a short and direct response. -40.33. What is the difference between the Domestic credit (% of GDP) in Congo (Democratic) in 2011 and the Domestic credit (% of GDP) in Seychelles in 2013?
Provide a succinct answer. -15.7. What is the difference between the Domestic credit (% of GDP) in Guyana in 2011 and the Domestic credit (% of GDP) in Seychelles in 2013?
Provide a succinct answer. 17.82. What is the difference between the Domestic credit (% of GDP) in Albania in 2012 and the Domestic credit (% of GDP) in Congo (Democratic) in 2013?
Keep it short and to the point. 33.35. What is the difference between the Domestic credit (% of GDP) of Albania in 2012 and the Domestic credit (% of GDP) of Guyana in 2013?
Your answer should be very brief. -5.63. What is the difference between the Domestic credit (% of GDP) in Albania in 2012 and the Domestic credit (% of GDP) in Seychelles in 2013?
Offer a very short reply. 19.01. What is the difference between the Domestic credit (% of GDP) of Congo (Democratic) in 2012 and the Domestic credit (% of GDP) of Guyana in 2013?
Make the answer very short. -39.55. What is the difference between the Domestic credit (% of GDP) of Congo (Democratic) in 2012 and the Domestic credit (% of GDP) of Seychelles in 2013?
Offer a terse response. -14.92. What is the difference between the Domestic credit (% of GDP) in Guyana in 2012 and the Domestic credit (% of GDP) in Seychelles in 2013?
Make the answer very short. 20.94. What is the average Domestic credit (% of GDP) of Albania per year?
Provide a succinct answer. 34.81. What is the average Domestic credit (% of GDP) of Congo (Democratic) per year?
Provide a short and direct response. 4.31. What is the average Domestic credit (% of GDP) in Guyana per year?
Your answer should be very brief. 37.96. What is the average Domestic credit (% of GDP) in Seychelles per year?
Make the answer very short. 22.79. In the year 2006, what is the difference between the Domestic credit (% of GDP) of Albania and Domestic credit (% of GDP) of Congo (Democratic)?
Offer a very short reply. 20.07. In the year 2006, what is the difference between the Domestic credit (% of GDP) of Albania and Domestic credit (% of GDP) of Guyana?
Your answer should be compact. -14.8. In the year 2006, what is the difference between the Domestic credit (% of GDP) of Albania and Domestic credit (% of GDP) of Seychelles?
Offer a very short reply. -0.59. In the year 2006, what is the difference between the Domestic credit (% of GDP) of Congo (Democratic) and Domestic credit (% of GDP) of Guyana?
Your answer should be very brief. -34.87. In the year 2006, what is the difference between the Domestic credit (% of GDP) in Congo (Democratic) and Domestic credit (% of GDP) in Seychelles?
Your response must be concise. -20.66. In the year 2006, what is the difference between the Domestic credit (% of GDP) in Guyana and Domestic credit (% of GDP) in Seychelles?
Offer a terse response. 14.21. In the year 2007, what is the difference between the Domestic credit (% of GDP) of Albania and Domestic credit (% of GDP) of Congo (Democratic)?
Provide a succinct answer. 27.26. In the year 2007, what is the difference between the Domestic credit (% of GDP) in Albania and Domestic credit (% of GDP) in Guyana?
Give a very brief answer. -5.12. In the year 2007, what is the difference between the Domestic credit (% of GDP) of Albania and Domestic credit (% of GDP) of Seychelles?
Your answer should be compact. 5.17. In the year 2007, what is the difference between the Domestic credit (% of GDP) of Congo (Democratic) and Domestic credit (% of GDP) of Guyana?
Give a very brief answer. -32.38. In the year 2007, what is the difference between the Domestic credit (% of GDP) in Congo (Democratic) and Domestic credit (% of GDP) in Seychelles?
Provide a succinct answer. -22.09. In the year 2007, what is the difference between the Domestic credit (% of GDP) in Guyana and Domestic credit (% of GDP) in Seychelles?
Offer a terse response. 10.29. In the year 2008, what is the difference between the Domestic credit (% of GDP) of Albania and Domestic credit (% of GDP) of Congo (Democratic)?
Your answer should be compact. 30.3. In the year 2008, what is the difference between the Domestic credit (% of GDP) of Albania and Domestic credit (% of GDP) of Guyana?
Your response must be concise. 1.08. In the year 2008, what is the difference between the Domestic credit (% of GDP) in Albania and Domestic credit (% of GDP) in Seychelles?
Keep it short and to the point. 7.56. In the year 2008, what is the difference between the Domestic credit (% of GDP) in Congo (Democratic) and Domestic credit (% of GDP) in Guyana?
Offer a terse response. -29.22. In the year 2008, what is the difference between the Domestic credit (% of GDP) in Congo (Democratic) and Domestic credit (% of GDP) in Seychelles?
Your response must be concise. -22.74. In the year 2008, what is the difference between the Domestic credit (% of GDP) of Guyana and Domestic credit (% of GDP) of Seychelles?
Provide a succinct answer. 6.49. In the year 2009, what is the difference between the Domestic credit (% of GDP) in Albania and Domestic credit (% of GDP) in Congo (Democratic)?
Your response must be concise. 31.51. In the year 2009, what is the difference between the Domestic credit (% of GDP) in Albania and Domestic credit (% of GDP) in Guyana?
Give a very brief answer. 0.43. In the year 2009, what is the difference between the Domestic credit (% of GDP) in Albania and Domestic credit (% of GDP) in Seychelles?
Ensure brevity in your answer.  16.84. In the year 2009, what is the difference between the Domestic credit (% of GDP) of Congo (Democratic) and Domestic credit (% of GDP) of Guyana?
Make the answer very short. -31.08. In the year 2009, what is the difference between the Domestic credit (% of GDP) in Congo (Democratic) and Domestic credit (% of GDP) in Seychelles?
Offer a terse response. -14.66. In the year 2009, what is the difference between the Domestic credit (% of GDP) in Guyana and Domestic credit (% of GDP) in Seychelles?
Your answer should be very brief. 16.42. In the year 2010, what is the difference between the Domestic credit (% of GDP) in Albania and Domestic credit (% of GDP) in Congo (Democratic)?
Make the answer very short. 33.59. In the year 2010, what is the difference between the Domestic credit (% of GDP) in Albania and Domestic credit (% of GDP) in Guyana?
Give a very brief answer. 0.26. In the year 2010, what is the difference between the Domestic credit (% of GDP) of Albania and Domestic credit (% of GDP) of Seychelles?
Provide a short and direct response. 13.06. In the year 2010, what is the difference between the Domestic credit (% of GDP) of Congo (Democratic) and Domestic credit (% of GDP) of Guyana?
Offer a terse response. -33.33. In the year 2010, what is the difference between the Domestic credit (% of GDP) in Congo (Democratic) and Domestic credit (% of GDP) in Seychelles?
Keep it short and to the point. -20.52. In the year 2010, what is the difference between the Domestic credit (% of GDP) in Guyana and Domestic credit (% of GDP) in Seychelles?
Keep it short and to the point. 12.8. In the year 2011, what is the difference between the Domestic credit (% of GDP) in Albania and Domestic credit (% of GDP) in Congo (Democratic)?
Offer a terse response. 35.1. In the year 2011, what is the difference between the Domestic credit (% of GDP) in Albania and Domestic credit (% of GDP) in Guyana?
Provide a short and direct response. 1.59. In the year 2011, what is the difference between the Domestic credit (% of GDP) of Albania and Domestic credit (% of GDP) of Seychelles?
Offer a very short reply. 17.22. In the year 2011, what is the difference between the Domestic credit (% of GDP) in Congo (Democratic) and Domestic credit (% of GDP) in Guyana?
Your answer should be very brief. -33.52. In the year 2011, what is the difference between the Domestic credit (% of GDP) in Congo (Democratic) and Domestic credit (% of GDP) in Seychelles?
Give a very brief answer. -17.89. In the year 2011, what is the difference between the Domestic credit (% of GDP) of Guyana and Domestic credit (% of GDP) of Seychelles?
Your answer should be very brief. 15.63. In the year 2012, what is the difference between the Domestic credit (% of GDP) of Albania and Domestic credit (% of GDP) of Congo (Democratic)?
Make the answer very short. 33.93. In the year 2012, what is the difference between the Domestic credit (% of GDP) in Albania and Domestic credit (% of GDP) in Guyana?
Provide a short and direct response. -1.94. In the year 2012, what is the difference between the Domestic credit (% of GDP) of Albania and Domestic credit (% of GDP) of Seychelles?
Offer a terse response. 19.02. In the year 2012, what is the difference between the Domestic credit (% of GDP) of Congo (Democratic) and Domestic credit (% of GDP) of Guyana?
Your response must be concise. -35.86. In the year 2012, what is the difference between the Domestic credit (% of GDP) of Congo (Democratic) and Domestic credit (% of GDP) of Seychelles?
Offer a terse response. -14.9. In the year 2012, what is the difference between the Domestic credit (% of GDP) in Guyana and Domestic credit (% of GDP) in Seychelles?
Offer a terse response. 20.96. In the year 2013, what is the difference between the Domestic credit (% of GDP) in Albania and Domestic credit (% of GDP) in Congo (Democratic)?
Give a very brief answer. 32.28. In the year 2013, what is the difference between the Domestic credit (% of GDP) of Albania and Domestic credit (% of GDP) of Guyana?
Your response must be concise. -6.69. In the year 2013, what is the difference between the Domestic credit (% of GDP) in Albania and Domestic credit (% of GDP) in Seychelles?
Your answer should be compact. 17.94. In the year 2013, what is the difference between the Domestic credit (% of GDP) of Congo (Democratic) and Domestic credit (% of GDP) of Guyana?
Provide a short and direct response. -38.98. In the year 2013, what is the difference between the Domestic credit (% of GDP) of Congo (Democratic) and Domestic credit (% of GDP) of Seychelles?
Give a very brief answer. -14.34. In the year 2013, what is the difference between the Domestic credit (% of GDP) in Guyana and Domestic credit (% of GDP) in Seychelles?
Offer a very short reply. 24.63. What is the ratio of the Domestic credit (% of GDP) in Albania in 2006 to that in 2007?
Your response must be concise. 0.74. What is the ratio of the Domestic credit (% of GDP) in Congo (Democratic) in 2006 to that in 2007?
Offer a very short reply. 0.78. What is the ratio of the Domestic credit (% of GDP) of Guyana in 2006 to that in 2007?
Provide a short and direct response. 1.05. What is the ratio of the Domestic credit (% of GDP) in Seychelles in 2006 to that in 2007?
Your answer should be very brief. 0.92. What is the ratio of the Domestic credit (% of GDP) of Albania in 2006 to that in 2008?
Your answer should be very brief. 0.63. What is the ratio of the Domestic credit (% of GDP) in Congo (Democratic) in 2006 to that in 2008?
Your response must be concise. 0.41. What is the ratio of the Domestic credit (% of GDP) in Guyana in 2006 to that in 2008?
Provide a short and direct response. 1.08. What is the ratio of the Domestic credit (% of GDP) in Seychelles in 2006 to that in 2008?
Your answer should be very brief. 0.82. What is the ratio of the Domestic credit (% of GDP) of Albania in 2006 to that in 2009?
Keep it short and to the point. 0.6. What is the ratio of the Domestic credit (% of GDP) of Congo (Democratic) in 2006 to that in 2009?
Make the answer very short. 0.39. What is the ratio of the Domestic credit (% of GDP) in Guyana in 2006 to that in 2009?
Your response must be concise. 1.01. What is the ratio of the Domestic credit (% of GDP) of Seychelles in 2006 to that in 2009?
Keep it short and to the point. 1.13. What is the ratio of the Domestic credit (% of GDP) in Albania in 2006 to that in 2010?
Your answer should be compact. 0.59. What is the ratio of the Domestic credit (% of GDP) in Congo (Democratic) in 2006 to that in 2010?
Make the answer very short. 0.54. What is the ratio of the Domestic credit (% of GDP) of Guyana in 2006 to that in 2010?
Ensure brevity in your answer.  0.99. What is the ratio of the Domestic credit (% of GDP) in Seychelles in 2006 to that in 2010?
Your answer should be compact. 0.93. What is the ratio of the Domestic credit (% of GDP) of Albania in 2006 to that in 2011?
Your response must be concise. 0.56. What is the ratio of the Domestic credit (% of GDP) of Congo (Democratic) in 2006 to that in 2011?
Your response must be concise. 0.48. What is the ratio of the Domestic credit (% of GDP) in Guyana in 2006 to that in 2011?
Offer a terse response. 0.98. What is the ratio of the Domestic credit (% of GDP) in Seychelles in 2006 to that in 2011?
Offer a very short reply. 1.02. What is the ratio of the Domestic credit (% of GDP) in Albania in 2006 to that in 2012?
Provide a succinct answer. 0.57. What is the ratio of the Domestic credit (% of GDP) of Congo (Democratic) in 2006 to that in 2012?
Keep it short and to the point. 0.41. What is the ratio of the Domestic credit (% of GDP) of Guyana in 2006 to that in 2012?
Keep it short and to the point. 0.9. What is the ratio of the Domestic credit (% of GDP) in Seychelles in 2006 to that in 2012?
Ensure brevity in your answer.  1.14. What is the ratio of the Domestic credit (% of GDP) in Albania in 2006 to that in 2013?
Provide a short and direct response. 0.58. What is the ratio of the Domestic credit (% of GDP) in Congo (Democratic) in 2006 to that in 2013?
Offer a very short reply. 0.37. What is the ratio of the Domestic credit (% of GDP) of Guyana in 2006 to that in 2013?
Keep it short and to the point. 0.83. What is the ratio of the Domestic credit (% of GDP) of Seychelles in 2006 to that in 2013?
Ensure brevity in your answer.  1.14. What is the ratio of the Domestic credit (% of GDP) in Albania in 2007 to that in 2008?
Make the answer very short. 0.85. What is the ratio of the Domestic credit (% of GDP) of Congo (Democratic) in 2007 to that in 2008?
Ensure brevity in your answer.  0.53. What is the ratio of the Domestic credit (% of GDP) in Guyana in 2007 to that in 2008?
Provide a short and direct response. 1.02. What is the ratio of the Domestic credit (% of GDP) in Seychelles in 2007 to that in 2008?
Your answer should be compact. 0.89. What is the ratio of the Domestic credit (% of GDP) of Albania in 2007 to that in 2009?
Offer a terse response. 0.81. What is the ratio of the Domestic credit (% of GDP) in Congo (Democratic) in 2007 to that in 2009?
Provide a succinct answer. 0.5. What is the ratio of the Domestic credit (% of GDP) of Guyana in 2007 to that in 2009?
Offer a very short reply. 0.96. What is the ratio of the Domestic credit (% of GDP) in Seychelles in 2007 to that in 2009?
Offer a terse response. 1.24. What is the ratio of the Domestic credit (% of GDP) of Albania in 2007 to that in 2010?
Your response must be concise. 0.8. What is the ratio of the Domestic credit (% of GDP) of Congo (Democratic) in 2007 to that in 2010?
Your response must be concise. 0.69. What is the ratio of the Domestic credit (% of GDP) of Guyana in 2007 to that in 2010?
Your answer should be very brief. 0.94. What is the ratio of the Domestic credit (% of GDP) of Seychelles in 2007 to that in 2010?
Your response must be concise. 1.01. What is the ratio of the Domestic credit (% of GDP) in Albania in 2007 to that in 2011?
Ensure brevity in your answer.  0.76. What is the ratio of the Domestic credit (% of GDP) in Congo (Democratic) in 2007 to that in 2011?
Provide a succinct answer. 0.62. What is the ratio of the Domestic credit (% of GDP) in Guyana in 2007 to that in 2011?
Provide a short and direct response. 0.93. What is the ratio of the Domestic credit (% of GDP) of Seychelles in 2007 to that in 2011?
Offer a very short reply. 1.11. What is the ratio of the Domestic credit (% of GDP) of Albania in 2007 to that in 2012?
Offer a very short reply. 0.77. What is the ratio of the Domestic credit (% of GDP) of Congo (Democratic) in 2007 to that in 2012?
Your response must be concise. 0.53. What is the ratio of the Domestic credit (% of GDP) in Guyana in 2007 to that in 2012?
Give a very brief answer. 0.86. What is the ratio of the Domestic credit (% of GDP) of Seychelles in 2007 to that in 2012?
Your response must be concise. 1.24. What is the ratio of the Domestic credit (% of GDP) of Albania in 2007 to that in 2013?
Ensure brevity in your answer.  0.79. What is the ratio of the Domestic credit (% of GDP) in Congo (Democratic) in 2007 to that in 2013?
Make the answer very short. 0.47. What is the ratio of the Domestic credit (% of GDP) in Guyana in 2007 to that in 2013?
Your answer should be very brief. 0.79. What is the ratio of the Domestic credit (% of GDP) of Seychelles in 2007 to that in 2013?
Your response must be concise. 1.24. What is the ratio of the Domestic credit (% of GDP) in Albania in 2008 to that in 2009?
Offer a terse response. 0.96. What is the ratio of the Domestic credit (% of GDP) of Congo (Democratic) in 2008 to that in 2009?
Keep it short and to the point. 0.95. What is the ratio of the Domestic credit (% of GDP) in Guyana in 2008 to that in 2009?
Provide a short and direct response. 0.94. What is the ratio of the Domestic credit (% of GDP) of Seychelles in 2008 to that in 2009?
Provide a succinct answer. 1.39. What is the ratio of the Domestic credit (% of GDP) in Albania in 2008 to that in 2010?
Provide a succinct answer. 0.94. What is the ratio of the Domestic credit (% of GDP) in Congo (Democratic) in 2008 to that in 2010?
Provide a short and direct response. 1.31. What is the ratio of the Domestic credit (% of GDP) of Guyana in 2008 to that in 2010?
Your response must be concise. 0.92. What is the ratio of the Domestic credit (% of GDP) of Seychelles in 2008 to that in 2010?
Provide a short and direct response. 1.14. What is the ratio of the Domestic credit (% of GDP) in Albania in 2008 to that in 2011?
Your answer should be compact. 0.9. What is the ratio of the Domestic credit (% of GDP) of Congo (Democratic) in 2008 to that in 2011?
Your answer should be compact. 1.18. What is the ratio of the Domestic credit (% of GDP) of Guyana in 2008 to that in 2011?
Your answer should be compact. 0.91. What is the ratio of the Domestic credit (% of GDP) in Seychelles in 2008 to that in 2011?
Your answer should be compact. 1.25. What is the ratio of the Domestic credit (% of GDP) in Albania in 2008 to that in 2012?
Provide a succinct answer. 0.91. What is the ratio of the Domestic credit (% of GDP) in Guyana in 2008 to that in 2012?
Provide a succinct answer. 0.84. What is the ratio of the Domestic credit (% of GDP) of Seychelles in 2008 to that in 2012?
Provide a short and direct response. 1.39. What is the ratio of the Domestic credit (% of GDP) of Albania in 2008 to that in 2013?
Your answer should be compact. 0.93. What is the ratio of the Domestic credit (% of GDP) in Congo (Democratic) in 2008 to that in 2013?
Offer a very short reply. 0.9. What is the ratio of the Domestic credit (% of GDP) in Guyana in 2008 to that in 2013?
Ensure brevity in your answer.  0.77. What is the ratio of the Domestic credit (% of GDP) of Seychelles in 2008 to that in 2013?
Provide a succinct answer. 1.39. What is the ratio of the Domestic credit (% of GDP) in Albania in 2009 to that in 2010?
Give a very brief answer. 0.98. What is the ratio of the Domestic credit (% of GDP) in Congo (Democratic) in 2009 to that in 2010?
Give a very brief answer. 1.38. What is the ratio of the Domestic credit (% of GDP) in Guyana in 2009 to that in 2010?
Ensure brevity in your answer.  0.98. What is the ratio of the Domestic credit (% of GDP) of Seychelles in 2009 to that in 2010?
Provide a succinct answer. 0.82. What is the ratio of the Domestic credit (% of GDP) in Albania in 2009 to that in 2011?
Provide a succinct answer. 0.94. What is the ratio of the Domestic credit (% of GDP) in Congo (Democratic) in 2009 to that in 2011?
Offer a terse response. 1.24. What is the ratio of the Domestic credit (% of GDP) of Guyana in 2009 to that in 2011?
Keep it short and to the point. 0.96. What is the ratio of the Domestic credit (% of GDP) of Seychelles in 2009 to that in 2011?
Provide a short and direct response. 0.9. What is the ratio of the Domestic credit (% of GDP) of Albania in 2009 to that in 2012?
Give a very brief answer. 0.95. What is the ratio of the Domestic credit (% of GDP) in Congo (Democratic) in 2009 to that in 2012?
Provide a short and direct response. 1.05. What is the ratio of the Domestic credit (% of GDP) of Guyana in 2009 to that in 2012?
Ensure brevity in your answer.  0.89. What is the ratio of the Domestic credit (% of GDP) in Albania in 2009 to that in 2013?
Keep it short and to the point. 0.97. What is the ratio of the Domestic credit (% of GDP) in Congo (Democratic) in 2009 to that in 2013?
Keep it short and to the point. 0.95. What is the ratio of the Domestic credit (% of GDP) of Guyana in 2009 to that in 2013?
Provide a succinct answer. 0.82. What is the ratio of the Domestic credit (% of GDP) of Albania in 2010 to that in 2011?
Your response must be concise. 0.95. What is the ratio of the Domestic credit (% of GDP) of Congo (Democratic) in 2010 to that in 2011?
Give a very brief answer. 0.9. What is the ratio of the Domestic credit (% of GDP) in Guyana in 2010 to that in 2011?
Provide a short and direct response. 0.98. What is the ratio of the Domestic credit (% of GDP) in Seychelles in 2010 to that in 2011?
Your answer should be very brief. 1.1. What is the ratio of the Domestic credit (% of GDP) of Albania in 2010 to that in 2012?
Offer a terse response. 0.96. What is the ratio of the Domestic credit (% of GDP) of Congo (Democratic) in 2010 to that in 2012?
Provide a succinct answer. 0.76. What is the ratio of the Domestic credit (% of GDP) of Guyana in 2010 to that in 2012?
Your answer should be compact. 0.91. What is the ratio of the Domestic credit (% of GDP) in Seychelles in 2010 to that in 2012?
Keep it short and to the point. 1.22. What is the ratio of the Domestic credit (% of GDP) of Albania in 2010 to that in 2013?
Your answer should be compact. 0.99. What is the ratio of the Domestic credit (% of GDP) of Congo (Democratic) in 2010 to that in 2013?
Make the answer very short. 0.69. What is the ratio of the Domestic credit (% of GDP) of Guyana in 2010 to that in 2013?
Provide a succinct answer. 0.83. What is the ratio of the Domestic credit (% of GDP) of Seychelles in 2010 to that in 2013?
Your answer should be very brief. 1.22. What is the ratio of the Domestic credit (% of GDP) in Albania in 2011 to that in 2012?
Give a very brief answer. 1.01. What is the ratio of the Domestic credit (% of GDP) of Congo (Democratic) in 2011 to that in 2012?
Keep it short and to the point. 0.85. What is the ratio of the Domestic credit (% of GDP) in Guyana in 2011 to that in 2012?
Your response must be concise. 0.92. What is the ratio of the Domestic credit (% of GDP) in Seychelles in 2011 to that in 2012?
Offer a terse response. 1.11. What is the ratio of the Domestic credit (% of GDP) in Albania in 2011 to that in 2013?
Offer a terse response. 1.04. What is the ratio of the Domestic credit (% of GDP) in Congo (Democratic) in 2011 to that in 2013?
Your answer should be compact. 0.76. What is the ratio of the Domestic credit (% of GDP) in Guyana in 2011 to that in 2013?
Offer a very short reply. 0.85. What is the ratio of the Domestic credit (% of GDP) of Seychelles in 2011 to that in 2013?
Provide a succinct answer. 1.11. What is the ratio of the Domestic credit (% of GDP) in Albania in 2012 to that in 2013?
Provide a short and direct response. 1.03. What is the ratio of the Domestic credit (% of GDP) of Congo (Democratic) in 2012 to that in 2013?
Your answer should be compact. 0.9. What is the ratio of the Domestic credit (% of GDP) of Guyana in 2012 to that in 2013?
Offer a terse response. 0.92. What is the difference between the highest and the second highest Domestic credit (% of GDP) in Albania?
Ensure brevity in your answer.  0.4. What is the difference between the highest and the second highest Domestic credit (% of GDP) in Congo (Democratic)?
Keep it short and to the point. 0.3. What is the difference between the highest and the second highest Domestic credit (% of GDP) of Guyana?
Your answer should be compact. 3.69. What is the difference between the highest and the second highest Domestic credit (% of GDP) of Seychelles?
Keep it short and to the point. 3.08. What is the difference between the highest and the lowest Domestic credit (% of GDP) in Albania?
Offer a terse response. 17.29. What is the difference between the highest and the lowest Domestic credit (% of GDP) of Congo (Democratic)?
Ensure brevity in your answer.  3.6. What is the difference between the highest and the lowest Domestic credit (% of GDP) of Guyana?
Provide a short and direct response. 10.32. What is the difference between the highest and the lowest Domestic credit (% of GDP) of Seychelles?
Provide a short and direct response. 7.84. 